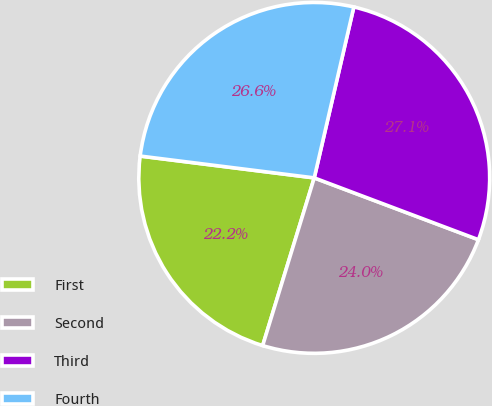Convert chart to OTSL. <chart><loc_0><loc_0><loc_500><loc_500><pie_chart><fcel>First<fcel>Second<fcel>Third<fcel>Fourth<nl><fcel>22.24%<fcel>24.02%<fcel>27.11%<fcel>26.64%<nl></chart> 